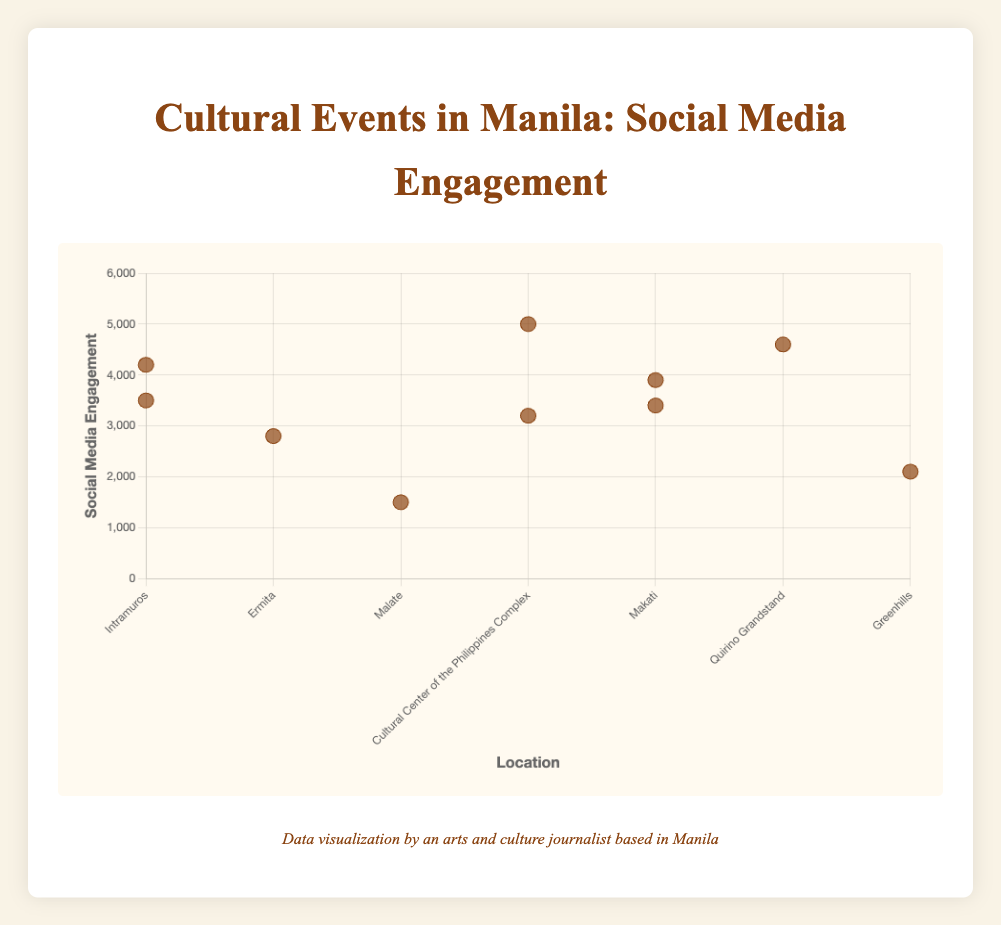What is the title of the figure? The title is at the top of the figure and indicates the overarching subject matter
Answer: Cultural Events in Manila: Social Media Engagement How many data points are displayed in the scatter plot? By counting the distinct markers on the scatter plot, the number of data points can be determined
Answer: 10 Which location has the highest social media engagement, and what is the value? Locate the data point that is highest on the vertical axis and identify the associated location and engagement value
Answer: Cultural Center of the Philippines Complex, 5000 Which event has the least social media engagement, and what is the value? Locate the data point that is lowest on the vertical axis and identify the event and engagement value
Answer: Cultural Dance Showcase, 1500 How many events are held in Intramuros? Identify the x-axis category "Intramuros" and count the markers above it
Answer: 2 What is the difference in social media engagement between the "Aliwan Fiesta" and "Music Museum Anniversary Concert"? Find the engagement values for both events (4600 for Aliwan Fiesta and 2100 for Music Museum Anniversary Concert), then subtract the smaller number from the larger number
Answer: 2500 What is the total social media engagement for the events held in Makati? Identify the markers placed above the "Makati" category and sum their corresponding engagement values (3400 for Fête de la Musique and 3900 for Art Fair Philippines)
Answer: 7300 Which event in Intramuros has higher social media engagement, and by how much? Compare the engagement values of "Intramuros Art Festival" (3500) and "Manila Biennale" (4200), then find the difference
Answer: Manila Biennale, 700 What is the average social media engagement for events held in the Cultural Center of the Philippines Complex? Identify the engagement values for events in this location (5000 for Cinemalaya Film Festival and 3200 for Pasinaya Open House Festival), then calculate their average (5000 + 3200 = 8200; 8200 / 2)
Answer: 4100 Which location has the most number of events and how does it compare in social media engagement to the location with the least number of events? Count the events per location, identify the locations with the most and the least number of events, then sum their engagement values for comparison
Answer: Most: Makati (7300), Least: Greenhills (2100); Makati has 5200 more engagement in total 